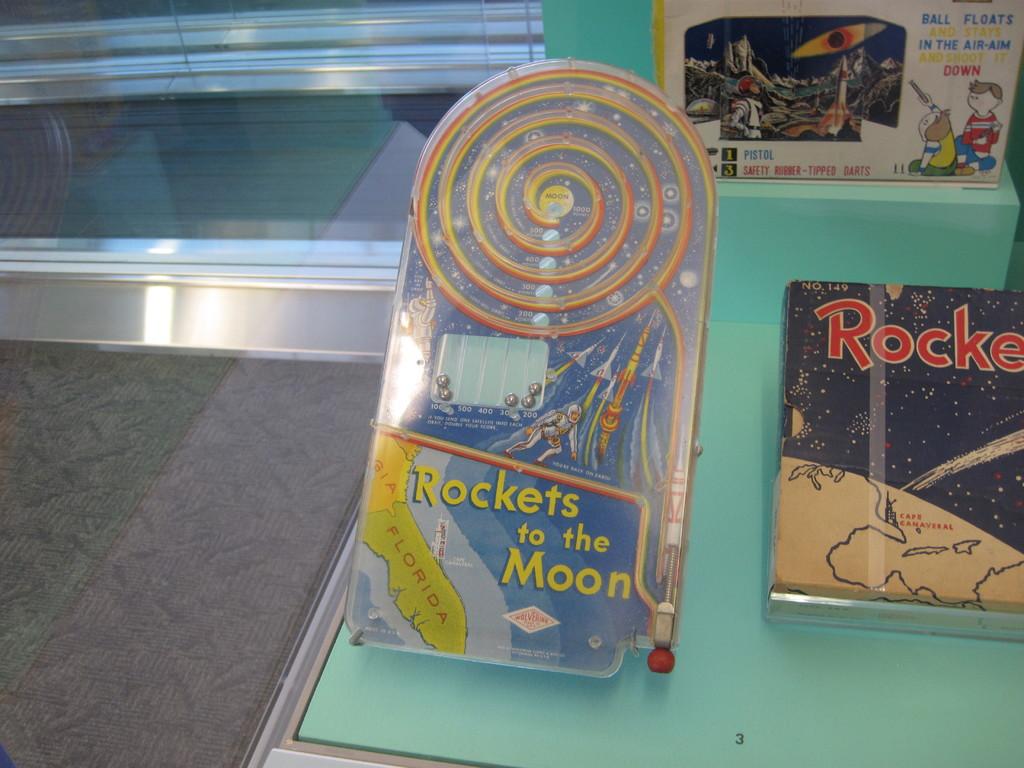Where are those tickets to?
Ensure brevity in your answer.  The moon. 